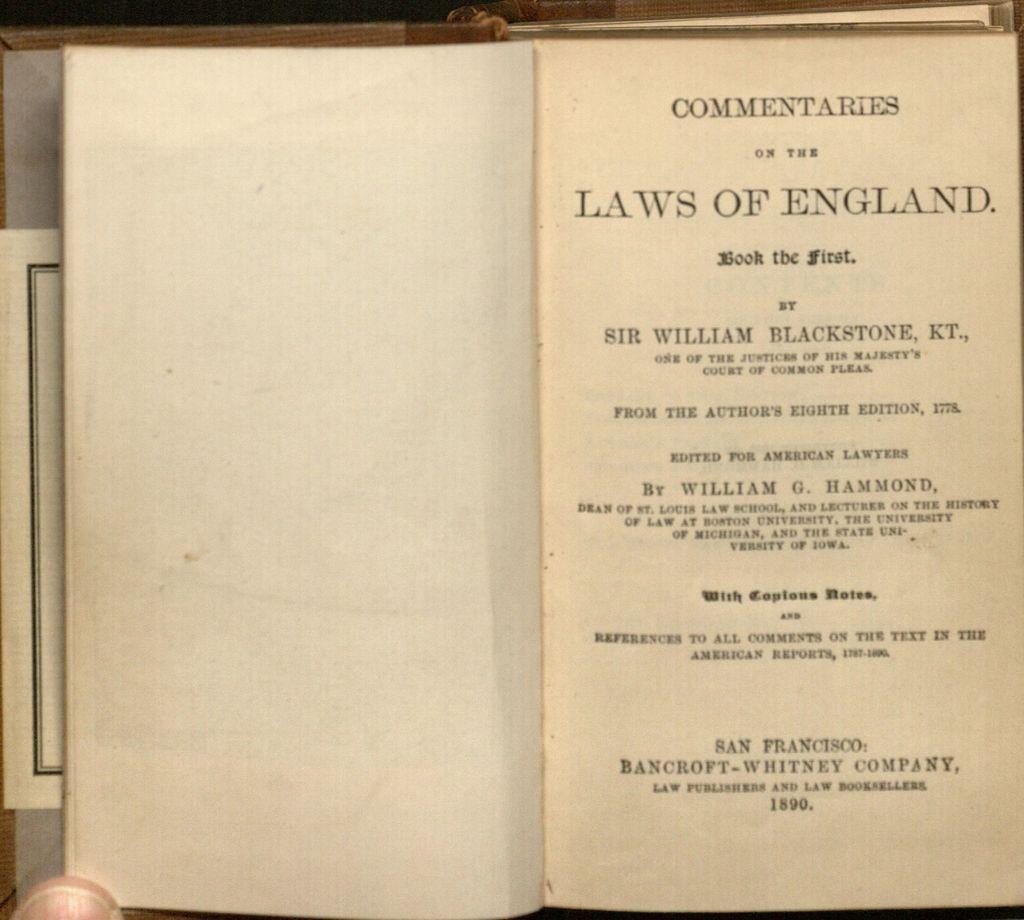This is the laws of what country?
Your response must be concise. England. Is sir william blackstone mentioned here?
Your answer should be compact. Yes. 